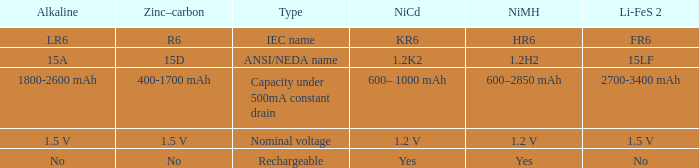What is Li-FeS 2, when Type is Nominal Voltage? 1.5 V. 